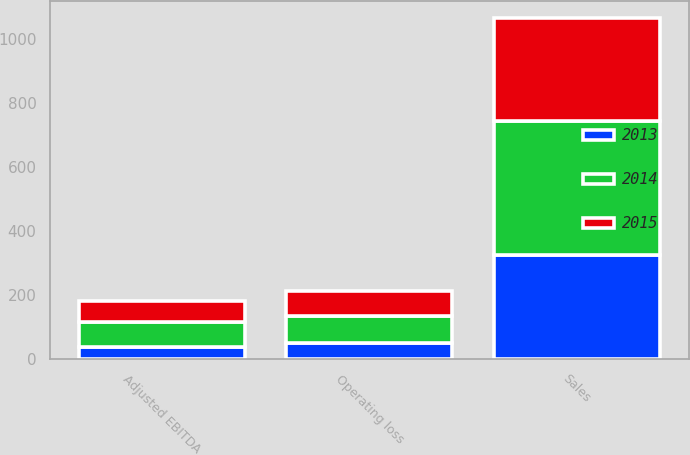Convert chart to OTSL. <chart><loc_0><loc_0><loc_500><loc_500><stacked_bar_chart><ecel><fcel>Sales<fcel>Operating loss<fcel>Adjusted EBITDA<nl><fcel>2013<fcel>324.7<fcel>50.6<fcel>37.6<nl><fcel>2015<fcel>322.2<fcel>77<fcel>66.2<nl><fcel>2014<fcel>418.3<fcel>84.3<fcel>77.8<nl></chart> 